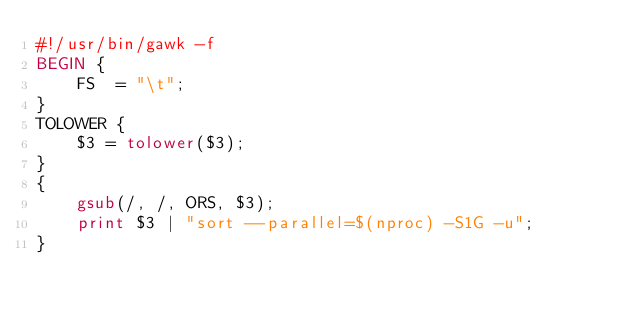<code> <loc_0><loc_0><loc_500><loc_500><_Awk_>#!/usr/bin/gawk -f
BEGIN {
    FS  = "\t";
}
TOLOWER {
    $3 = tolower($3);
}
{
    gsub(/, /, ORS, $3);
    print $3 | "sort --parallel=$(nproc) -S1G -u";
}
</code> 